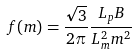<formula> <loc_0><loc_0><loc_500><loc_500>f ( m ) = \frac { \sqrt { 3 } } { 2 \pi } \frac { L _ { p } B } { L _ { m } ^ { 2 } m ^ { 2 } }</formula> 